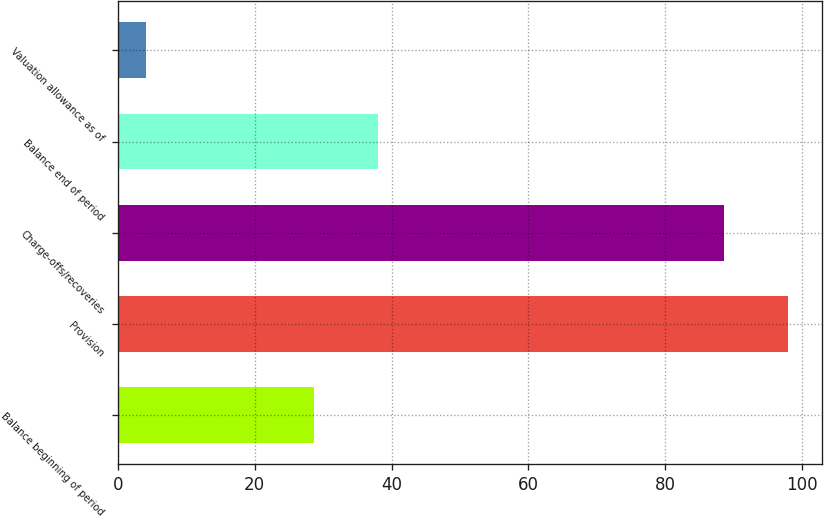<chart> <loc_0><loc_0><loc_500><loc_500><bar_chart><fcel>Balance beginning of period<fcel>Provision<fcel>Charge-offs/recoveries<fcel>Balance end of period<fcel>Valuation allowance as of<nl><fcel>28.7<fcel>97.95<fcel>88.6<fcel>38.05<fcel>4.1<nl></chart> 